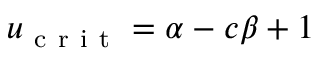Convert formula to latex. <formula><loc_0><loc_0><loc_500><loc_500>u _ { c r i t } = \alpha - c \beta + 1</formula> 